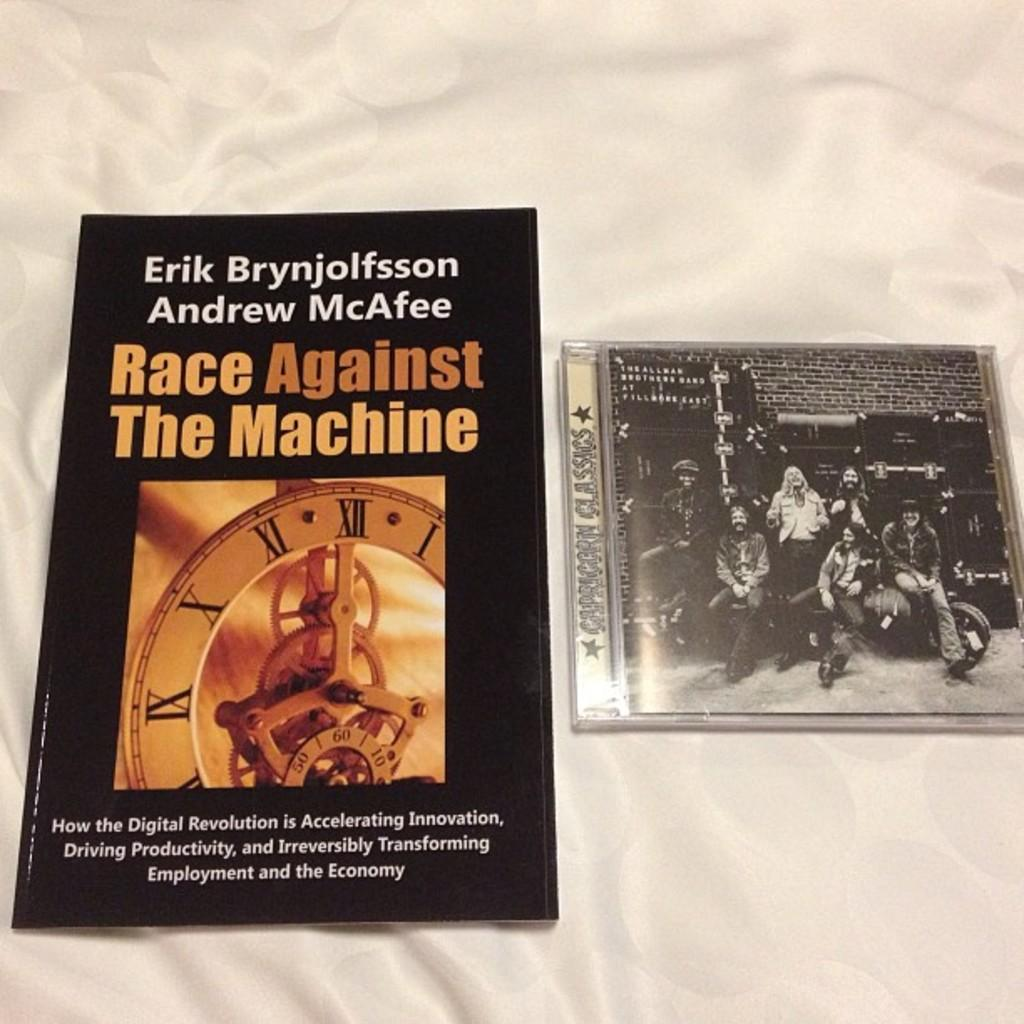<image>
Describe the image concisely. a book titled 'race against the machine' by erik brynjolfsson and andrew macafee 